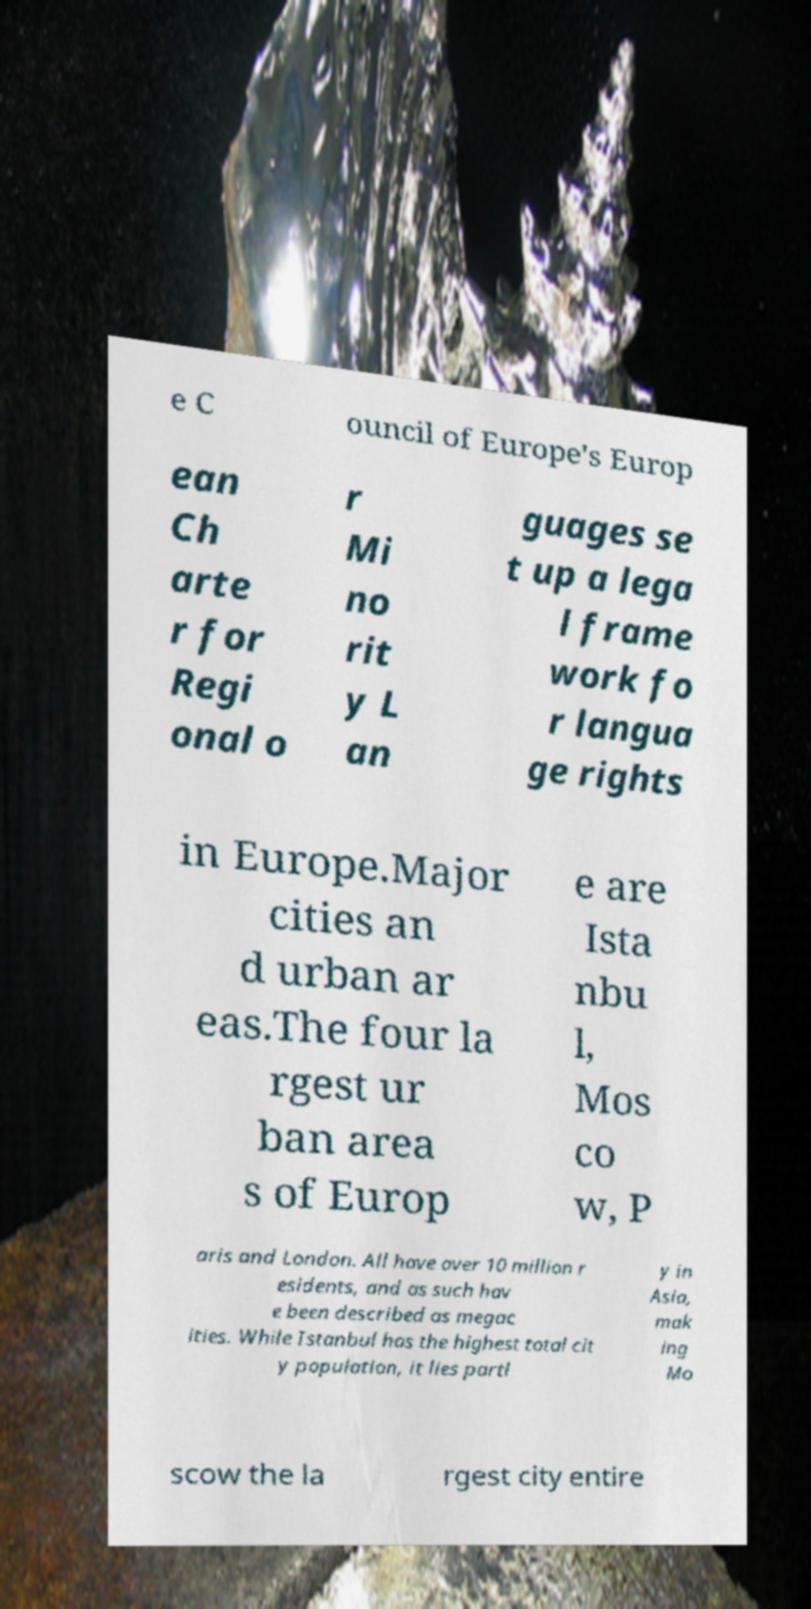Please identify and transcribe the text found in this image. e C ouncil of Europe's Europ ean Ch arte r for Regi onal o r Mi no rit y L an guages se t up a lega l frame work fo r langua ge rights in Europe.Major cities an d urban ar eas.The four la rgest ur ban area s of Europ e are Ista nbu l, Mos co w, P aris and London. All have over 10 million r esidents, and as such hav e been described as megac ities. While Istanbul has the highest total cit y population, it lies partl y in Asia, mak ing Mo scow the la rgest city entire 